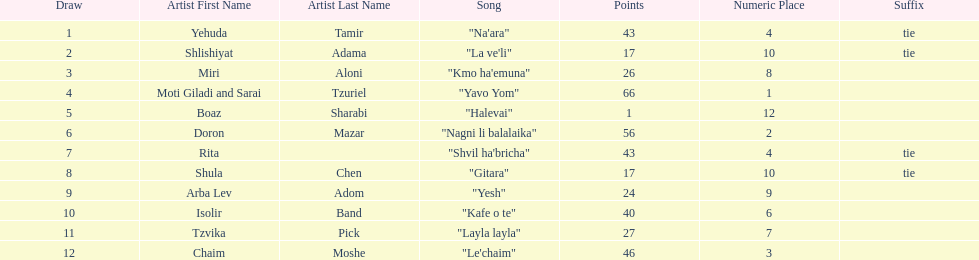Did the song "gitara" or "yesh" earn more points? "Yesh". 